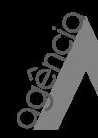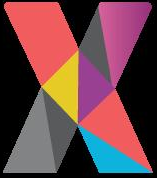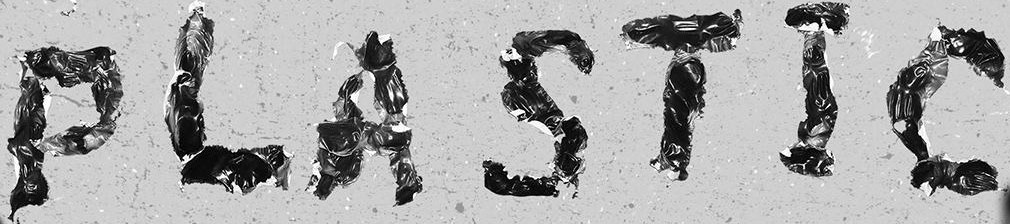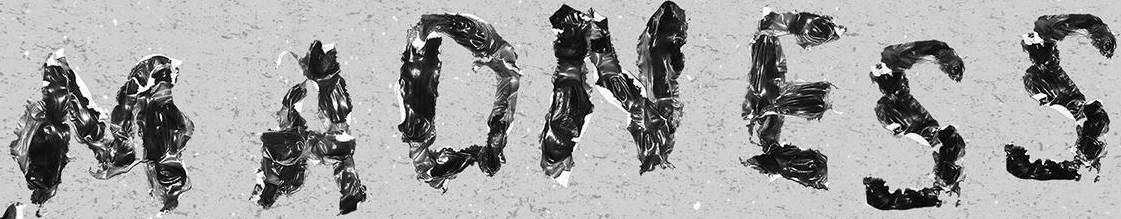Identify the words shown in these images in order, separated by a semicolon. agência; X; PLASTIC; MADNESS 